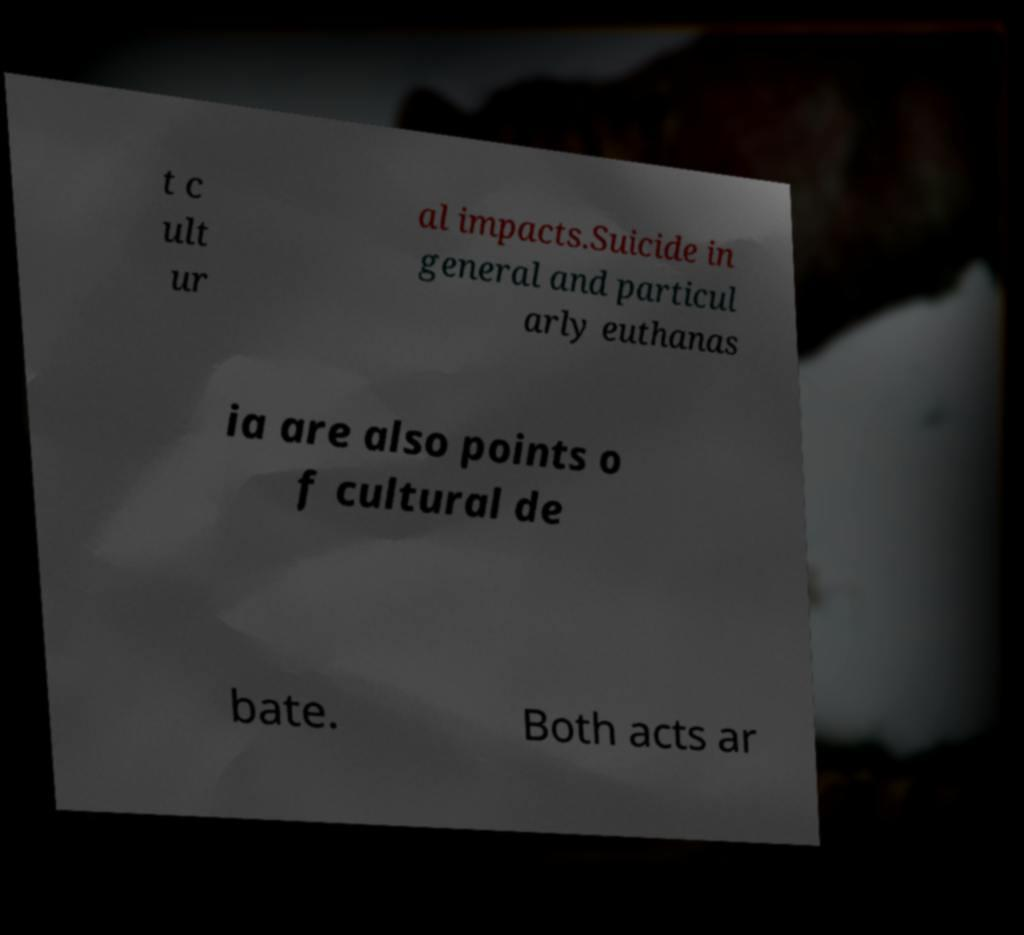Can you read and provide the text displayed in the image?This photo seems to have some interesting text. Can you extract and type it out for me? t c ult ur al impacts.Suicide in general and particul arly euthanas ia are also points o f cultural de bate. Both acts ar 